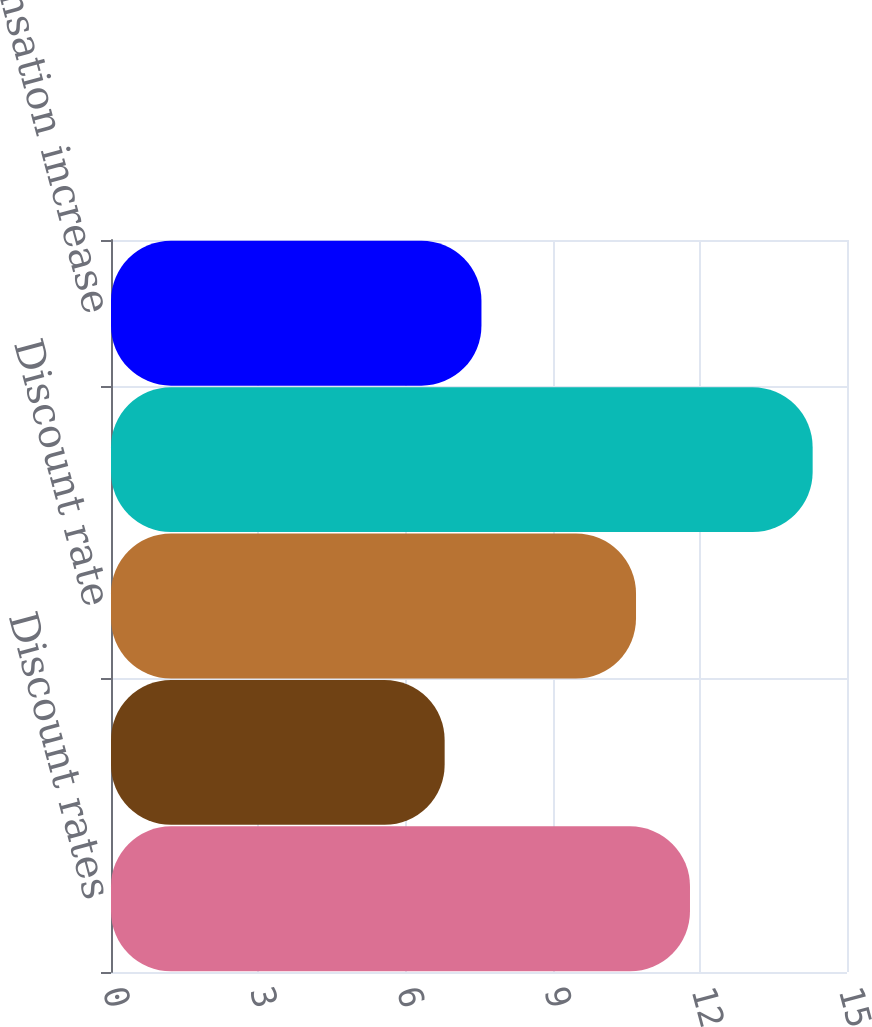Convert chart to OTSL. <chart><loc_0><loc_0><loc_500><loc_500><bar_chart><fcel>Discount rates<fcel>Rates of compensation increase<fcel>Discount rate<fcel>Expected long-term rate of<fcel>Rate of compensation increase<nl><fcel>11.8<fcel>6.8<fcel>10.7<fcel>14.3<fcel>7.55<nl></chart> 